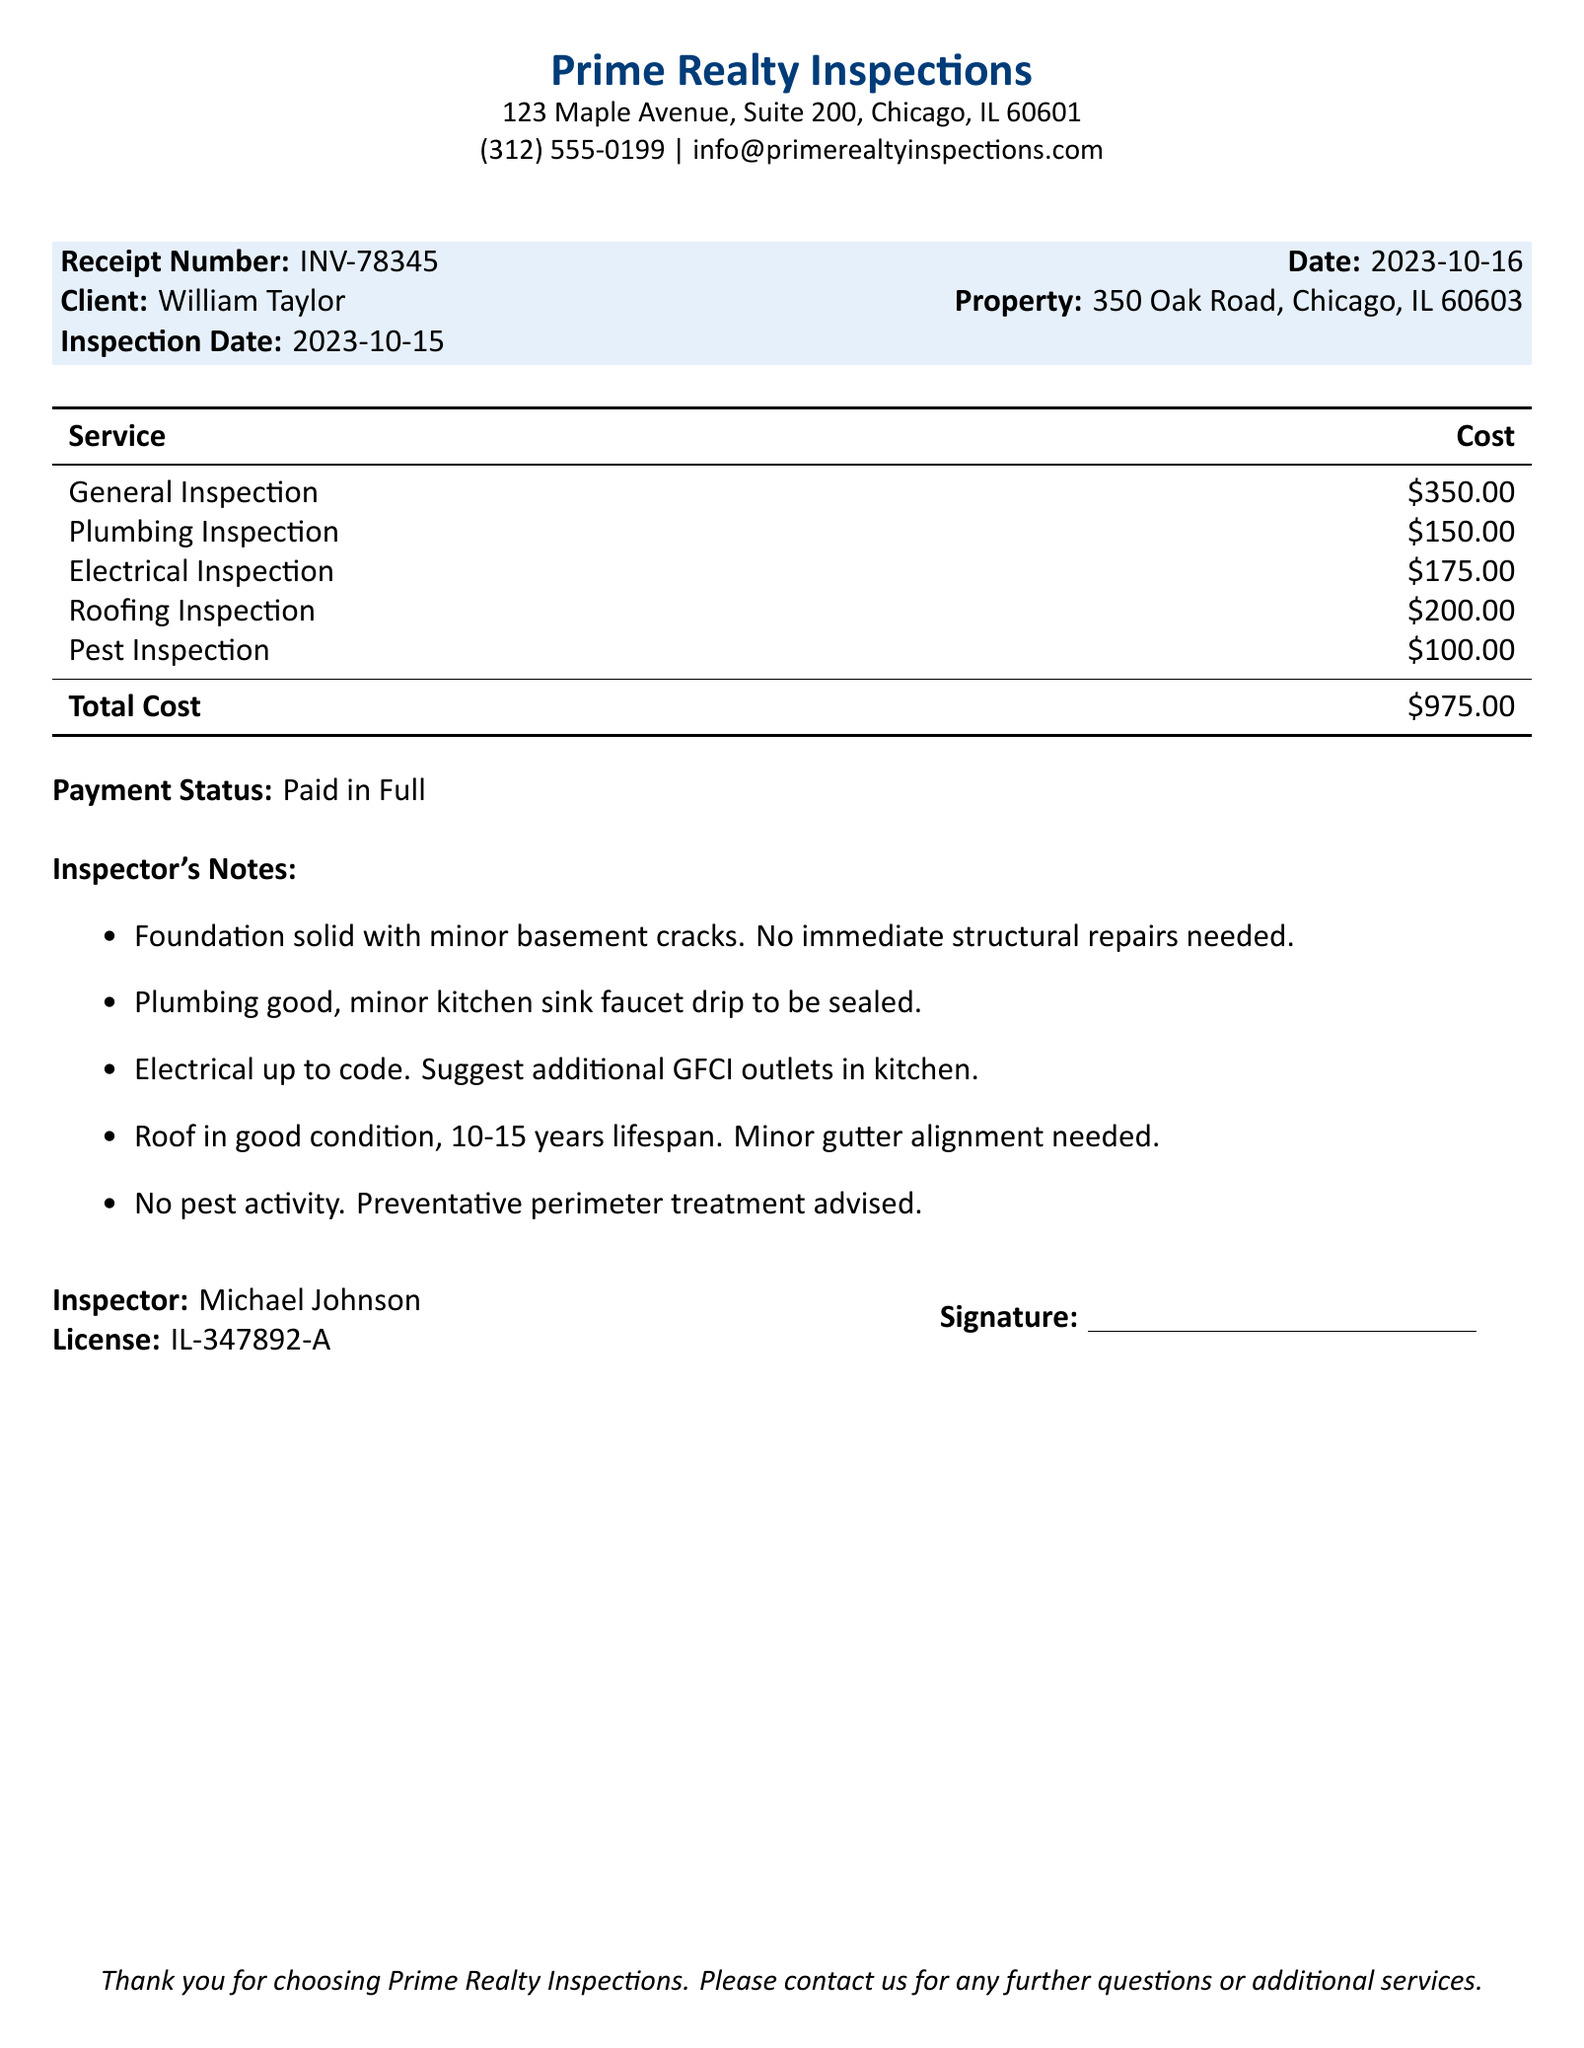What is the receipt number? The receipt number is listed in the document as INV-78345.
Answer: INV-78345 Who is the client? The client's name is specified in the document as William Taylor.
Answer: William Taylor What is the inspection date? The inspection date is mentioned in the document as 2023-10-15.
Answer: 2023-10-15 What is the total cost for the inspections? The total cost is provided at the bottom of the services table as $975.00.
Answer: $975.00 What does the inspector suggest for the electrical system? The inspector notes a suggestion for additional GFCI outlets in the kitchen.
Answer: Additional GFCI outlets in kitchen How many inspections were performed? The document lists five specific inspections conducted for the property.
Answer: Five What is the payment status? The payment status is stated in the document as "Paid in Full."
Answer: Paid in Full What are the minor issues noted in the plumbing inspection? The plumbing inspection identified a minor kitchen sink faucet drip that needs to be sealed.
Answer: Minor kitchen sink faucet drip to be sealed What is the license number of the inspector? The inspector's license number is provided in the document as IL-347892-A.
Answer: IL-347892-A 